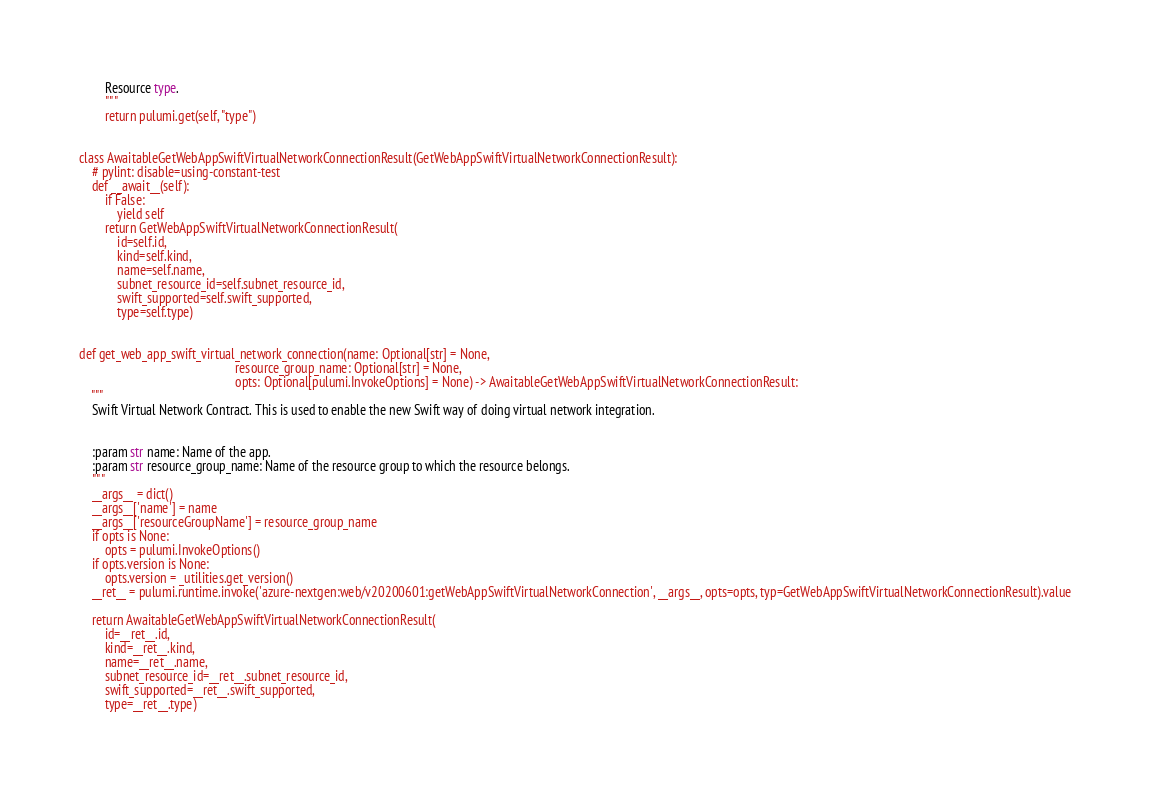<code> <loc_0><loc_0><loc_500><loc_500><_Python_>        Resource type.
        """
        return pulumi.get(self, "type")


class AwaitableGetWebAppSwiftVirtualNetworkConnectionResult(GetWebAppSwiftVirtualNetworkConnectionResult):
    # pylint: disable=using-constant-test
    def __await__(self):
        if False:
            yield self
        return GetWebAppSwiftVirtualNetworkConnectionResult(
            id=self.id,
            kind=self.kind,
            name=self.name,
            subnet_resource_id=self.subnet_resource_id,
            swift_supported=self.swift_supported,
            type=self.type)


def get_web_app_swift_virtual_network_connection(name: Optional[str] = None,
                                                 resource_group_name: Optional[str] = None,
                                                 opts: Optional[pulumi.InvokeOptions] = None) -> AwaitableGetWebAppSwiftVirtualNetworkConnectionResult:
    """
    Swift Virtual Network Contract. This is used to enable the new Swift way of doing virtual network integration.


    :param str name: Name of the app.
    :param str resource_group_name: Name of the resource group to which the resource belongs.
    """
    __args__ = dict()
    __args__['name'] = name
    __args__['resourceGroupName'] = resource_group_name
    if opts is None:
        opts = pulumi.InvokeOptions()
    if opts.version is None:
        opts.version = _utilities.get_version()
    __ret__ = pulumi.runtime.invoke('azure-nextgen:web/v20200601:getWebAppSwiftVirtualNetworkConnection', __args__, opts=opts, typ=GetWebAppSwiftVirtualNetworkConnectionResult).value

    return AwaitableGetWebAppSwiftVirtualNetworkConnectionResult(
        id=__ret__.id,
        kind=__ret__.kind,
        name=__ret__.name,
        subnet_resource_id=__ret__.subnet_resource_id,
        swift_supported=__ret__.swift_supported,
        type=__ret__.type)
</code> 